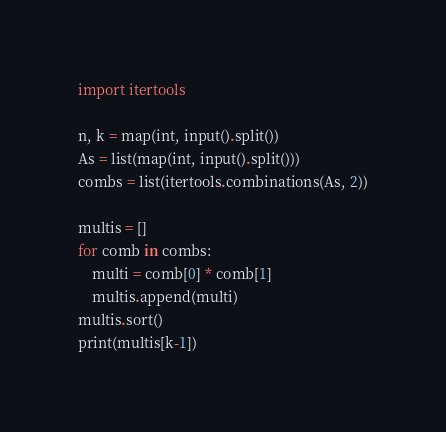Convert code to text. <code><loc_0><loc_0><loc_500><loc_500><_Python_>import itertools

n, k = map(int, input().split())
As = list(map(int, input().split()))
combs = list(itertools.combinations(As, 2))

multis = []
for comb in combs:
    multi = comb[0] * comb[1]
    multis.append(multi)
multis.sort()
print(multis[k-1])</code> 